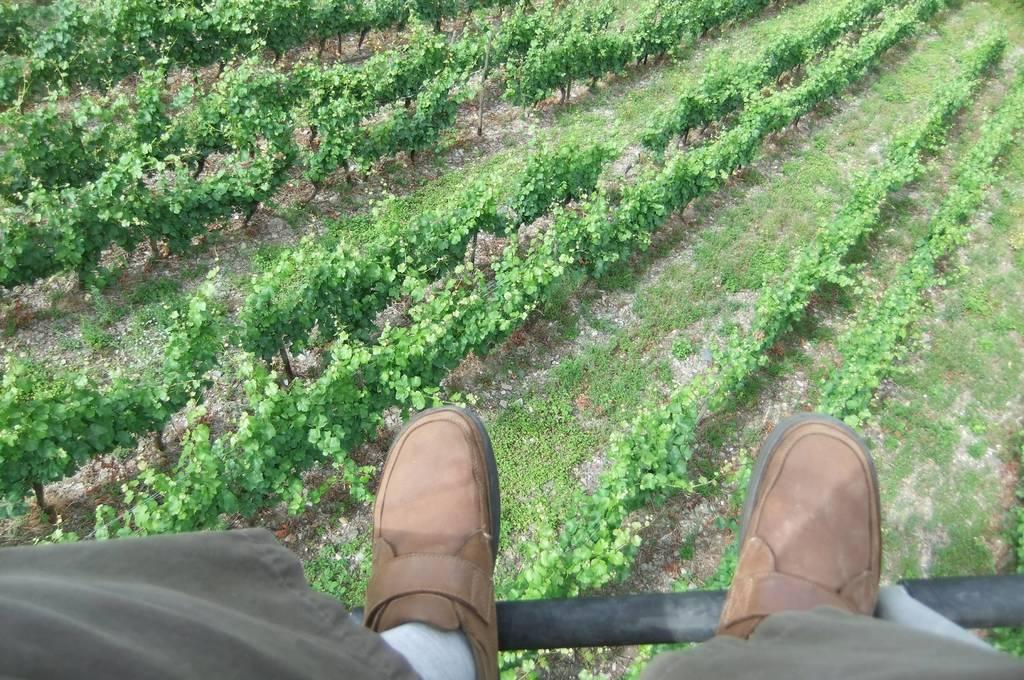What is visible in the foreground of the picture? There are feet of a person in the foreground of the picture. What is the iron object that the feet are lying on? The feet are lying on an iron object. What can be seen in the center of the picture? There are plants in the center of the picture, possibly forming a field. What type of tin can be seen in the picture? There is no tin present in the picture. How does the fold of the person's clothing look in the picture? The provided facts do not mention any clothing or folds, so it cannot be determined from the image. 